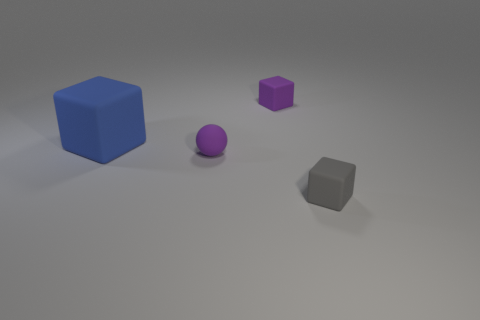What material is the gray thing that is the same size as the purple rubber ball? The gray object appears to be made of a matte material with a texture similar to rubber or plastic, much like the purple ball. 